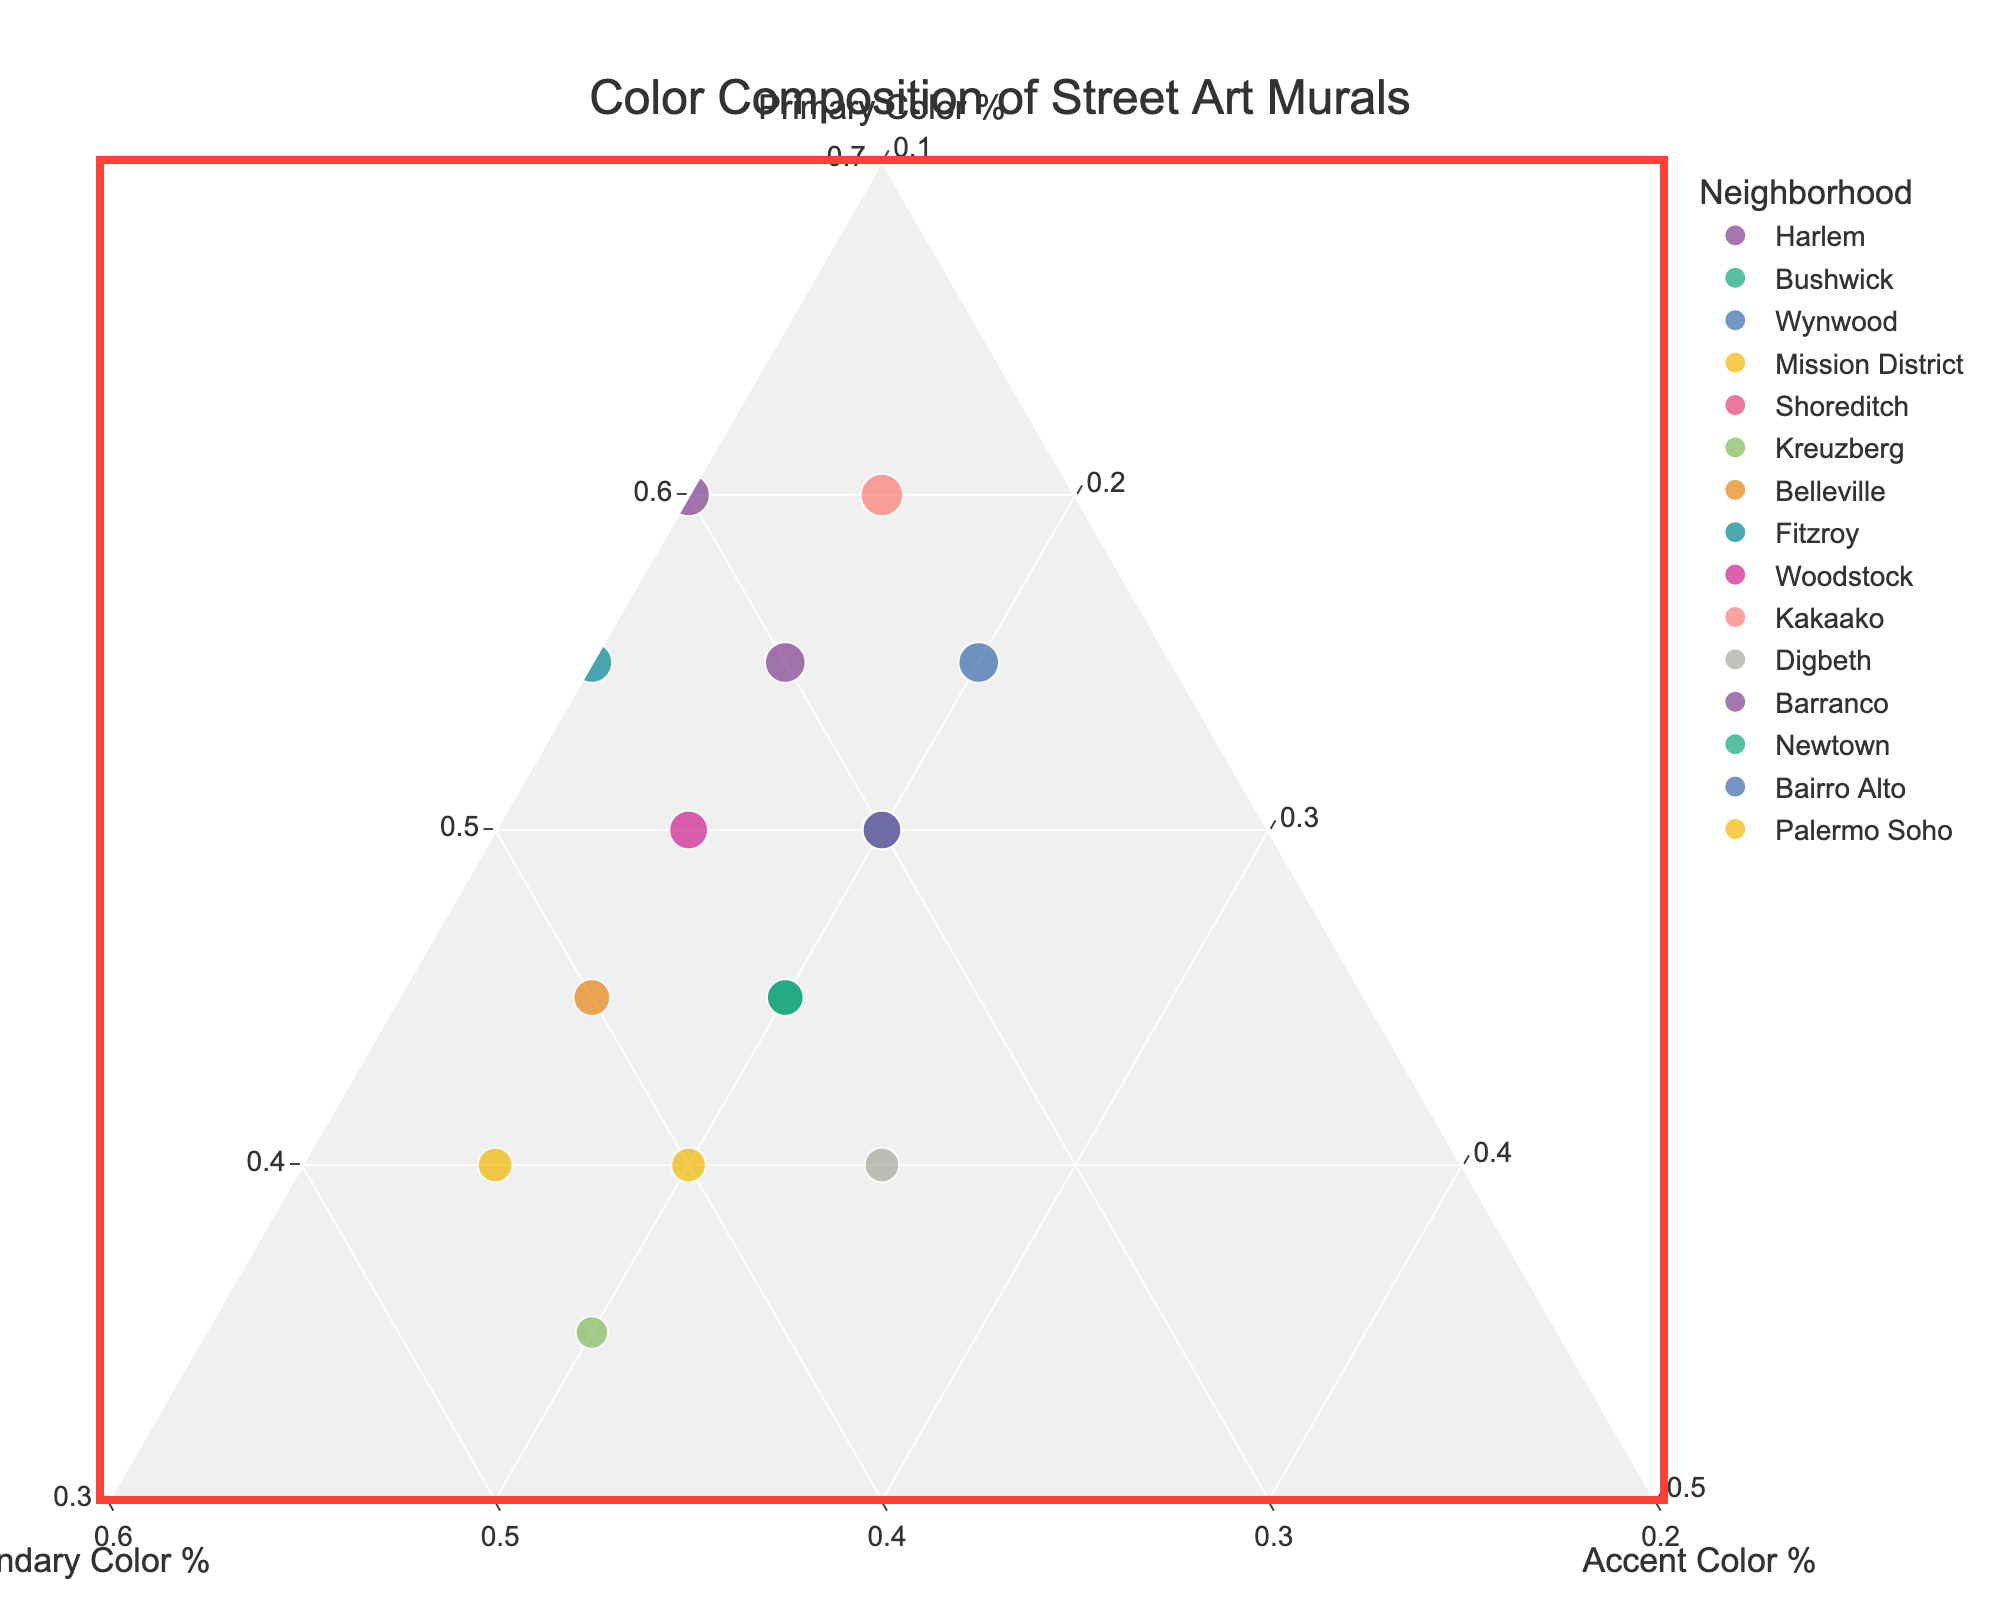what is the title of this plot? At the top center of the plot, there's a text element that describes the figure. The title reads "Color Composition of Street Art Murals," indicating what the plot represents.
Answer: Color Composition of Street Art Murals Which neighborhood has the highest percentage of Primary Color? To find this, look at the data points positioned closest to the ternary axis labeled "Primary Color %." Harlem is the highest with a value of 60%.
Answer: Harlem What percentage of Accent Color is used in Digbeth? Find the data point labeled "Digbeth" on the plot. Observing its position relative to the "Accent Color %" axis, we can determine it is 25%.
Answer: 25% Which neighborhood has a higher Primary Color %, Harlem or Bushwick? Compare the positions of Harlem and Bushwick along the "Primary Color %" axis. Harlem is at 60%, while Bushwick is at 45%. Hence, Harlem has a higher Primary Color %.
Answer: Harlem Which neighborhoods have equal Secondary Color %? Look for neighborhoods aligning at the same position along the "Secondary Color %" axis. Belleville and Bushwick both align at 35%.
Answer: Belleville, Bushwick Calculate the average Accent Color % for the neighborhoods listed Add up all the Accent Color % values from the data, then divide by the number of neighborhoods. (10 + 20 + 20 + 20 + 20 + 20 + 15 + 10 + 15 + 15 + 25 + 15 + 20 + 20 + 15) / 15 = 17.
Answer: 17% What is unique about the color composition of Kreuzberg? Kreuzberg stands out because it has the highest Secondary Color % at 45%, which is the maximum among the listed neighborhoods.
Answer: Highest Secondary Color % 